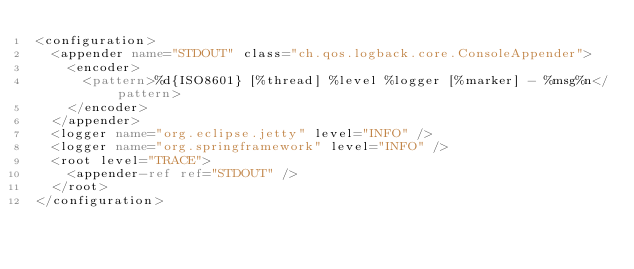<code> <loc_0><loc_0><loc_500><loc_500><_XML_><configuration>
  <appender name="STDOUT" class="ch.qos.logback.core.ConsoleAppender">
    <encoder>
      <pattern>%d{ISO8601} [%thread] %level %logger [%marker] - %msg%n</pattern>
    </encoder>
  </appender>
  <logger name="org.eclipse.jetty" level="INFO" />
  <logger name="org.springframework" level="INFO" />
  <root level="TRACE">
    <appender-ref ref="STDOUT" />
  </root>
</configuration></code> 